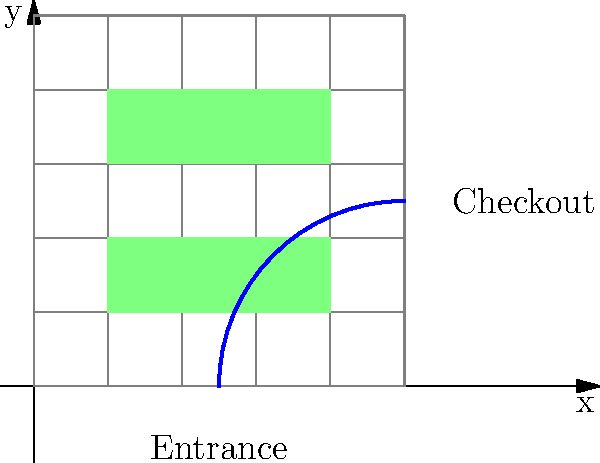You want to optimize your store layout using a 5x5 grid system. The entrance is at $(2.5, 0)$ and the checkout is at $(5, 2.5)$. Two shelving units are placed at coordinates $(1,1)$ to $(4,2)$ and $(1,3)$ to $(4,4)$. What is the minimum distance a customer must travel from the entrance to the checkout, assuming they must walk around the shelves? To find the minimum distance, we need to follow these steps:

1. Identify the path constraints:
   - Start at the entrance $(2.5, 0)$
   - End at the checkout $(5, 2.5)$
   - Avoid passing through shelves

2. Determine the shortest path:
   - Move vertically from $(2.5, 0)$ to $(2.5, 2.5)$
   - Then move horizontally from $(2.5, 2.5)$ to $(5, 2.5)$

3. Calculate the distance:
   - Vertical distance: $2.5 - 0 = 2.5$ units
   - Horizontal distance: $5 - 2.5 = 2.5$ units
   - Total distance: $2.5 + 2.5 = 5$ units

Therefore, the minimum distance a customer must travel is 5 units on the grid.
Answer: 5 units 